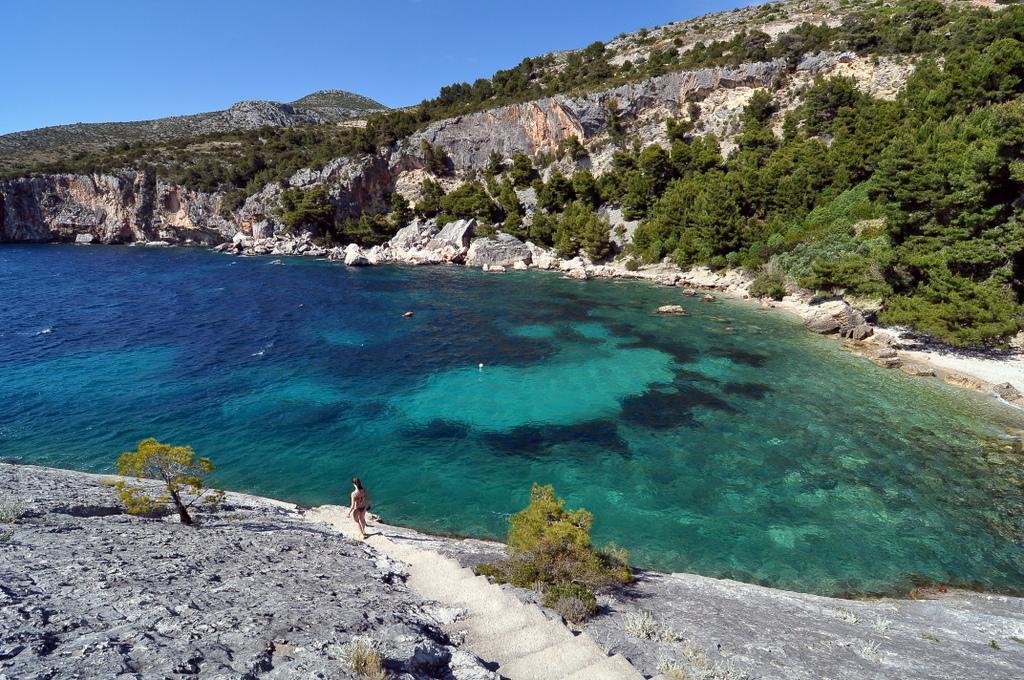Please provide a concise description of this image. In this image we can see water, blue sky, rocks, trees, steps and person. 